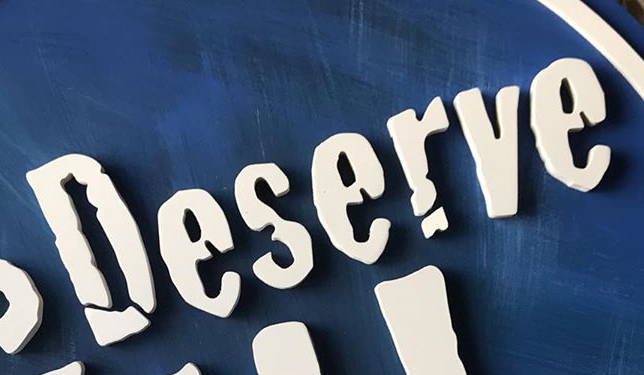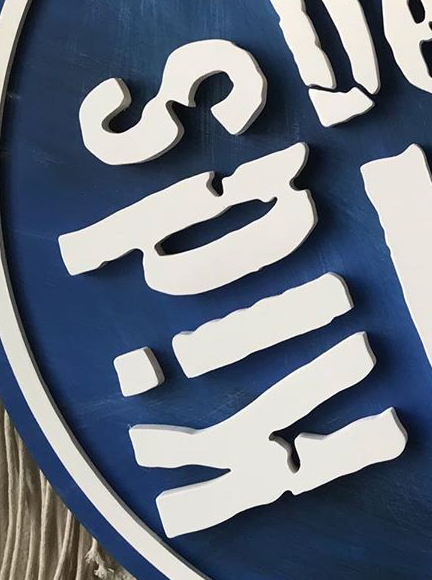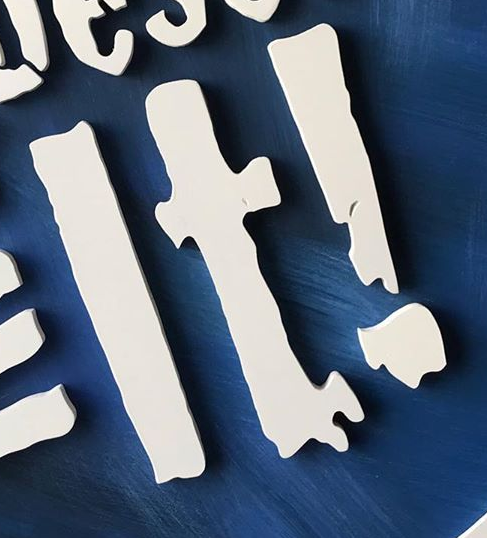Transcribe the words shown in these images in order, separated by a semicolon. Deserve; Kids; It! 